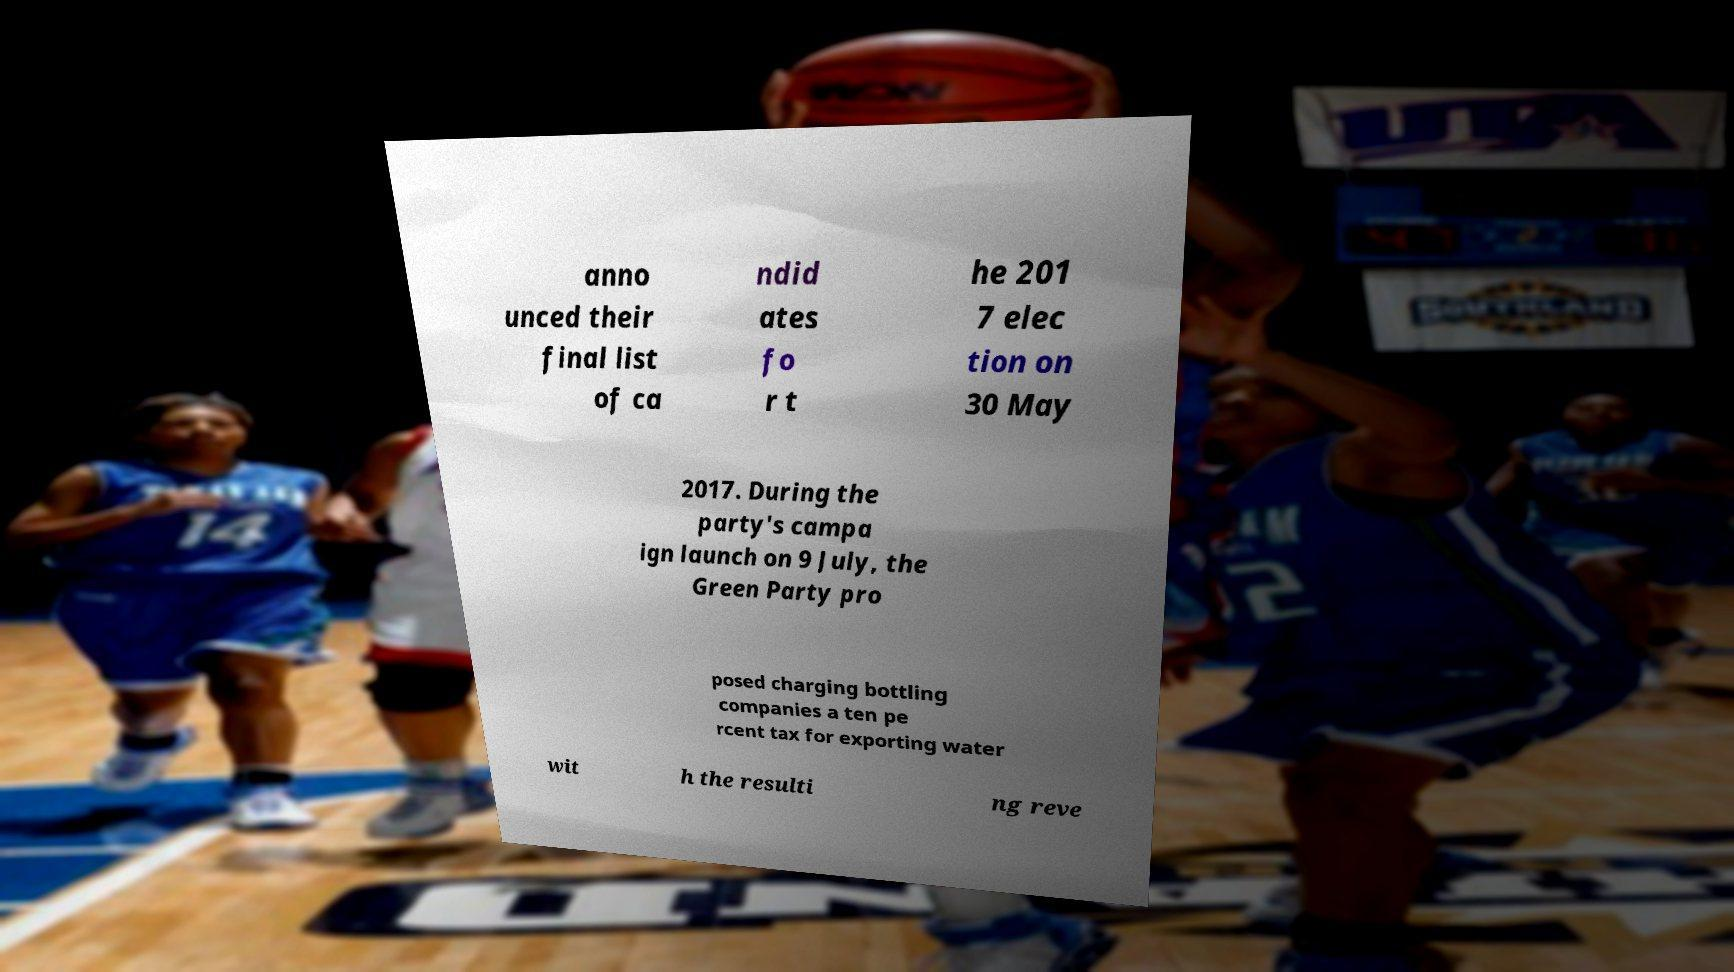I need the written content from this picture converted into text. Can you do that? anno unced their final list of ca ndid ates fo r t he 201 7 elec tion on 30 May 2017. During the party's campa ign launch on 9 July, the Green Party pro posed charging bottling companies a ten pe rcent tax for exporting water wit h the resulti ng reve 